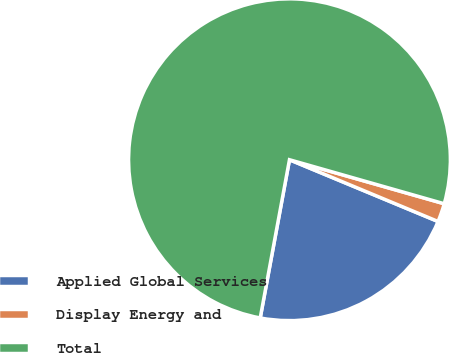Convert chart to OTSL. <chart><loc_0><loc_0><loc_500><loc_500><pie_chart><fcel>Applied Global Services<fcel>Display Energy and<fcel>Total<nl><fcel>21.64%<fcel>1.86%<fcel>76.5%<nl></chart> 